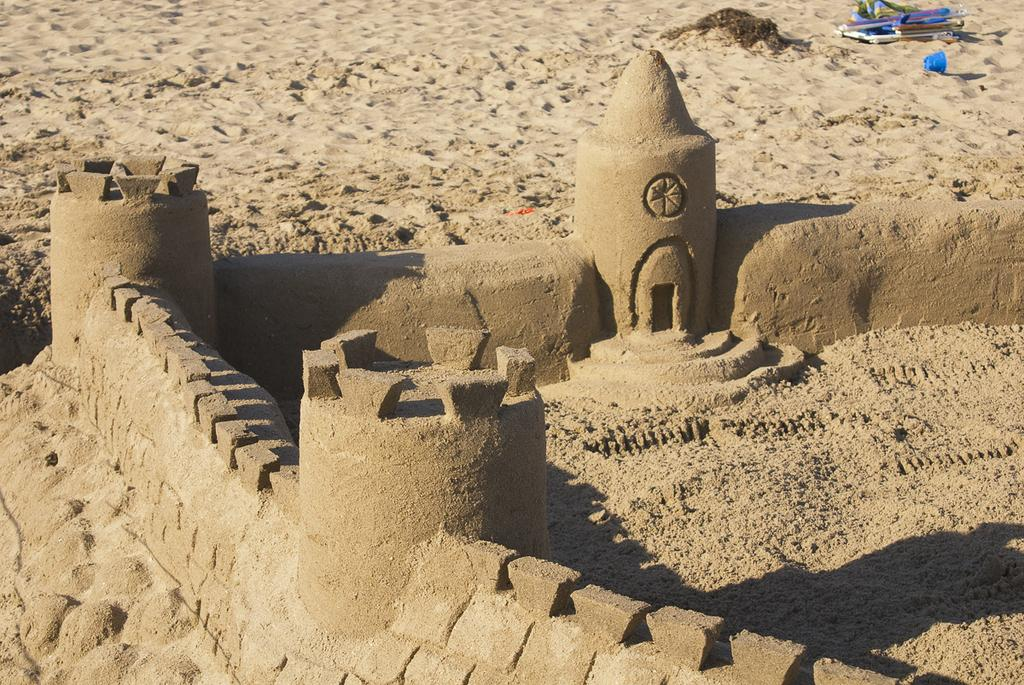What is the main structure visible in the image? There is a sand castle in the image. What else can be seen on the sand in the image? There are objects on the sand in the image. What type of pie is being served on the sand in the image? There is no pie present in the image; it features a sand castle and objects on the sand. What type of crack can be seen in the image? There is no crack present in the image; it features a sand castle and objects on the sand. 